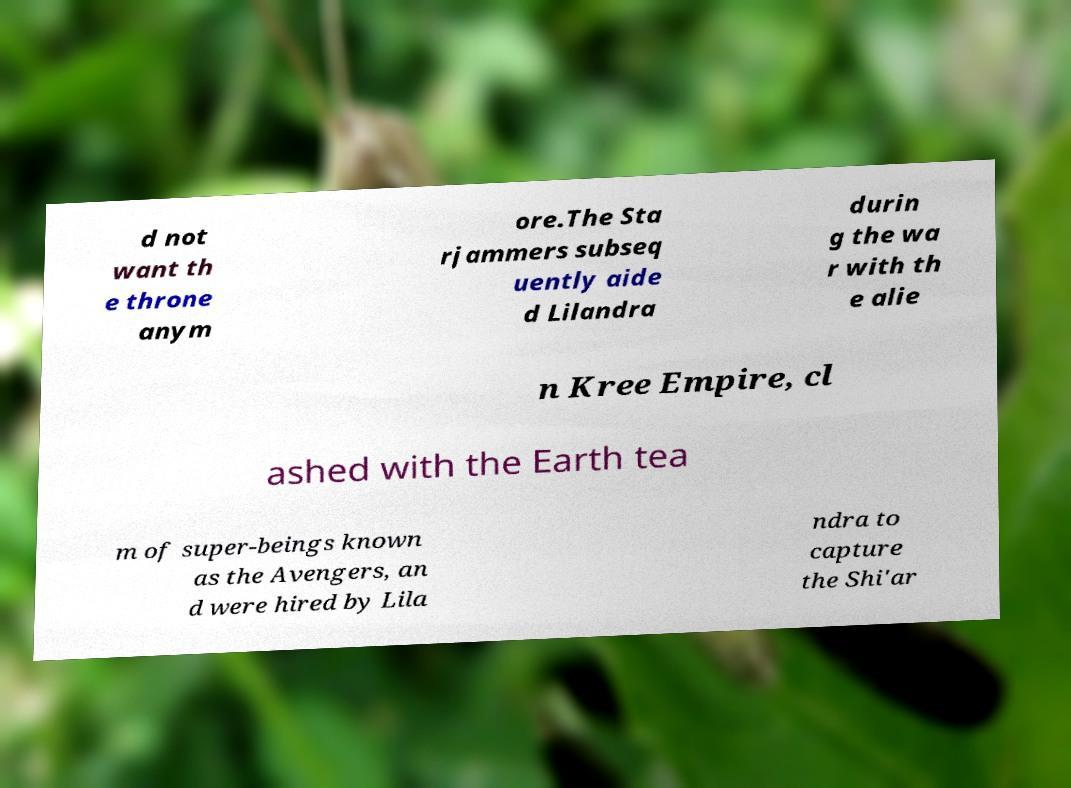Please identify and transcribe the text found in this image. d not want th e throne anym ore.The Sta rjammers subseq uently aide d Lilandra durin g the wa r with th e alie n Kree Empire, cl ashed with the Earth tea m of super-beings known as the Avengers, an d were hired by Lila ndra to capture the Shi'ar 